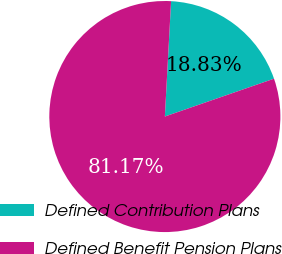<chart> <loc_0><loc_0><loc_500><loc_500><pie_chart><fcel>Defined Contribution Plans<fcel>Defined Benefit Pension Plans<nl><fcel>18.83%<fcel>81.17%<nl></chart> 